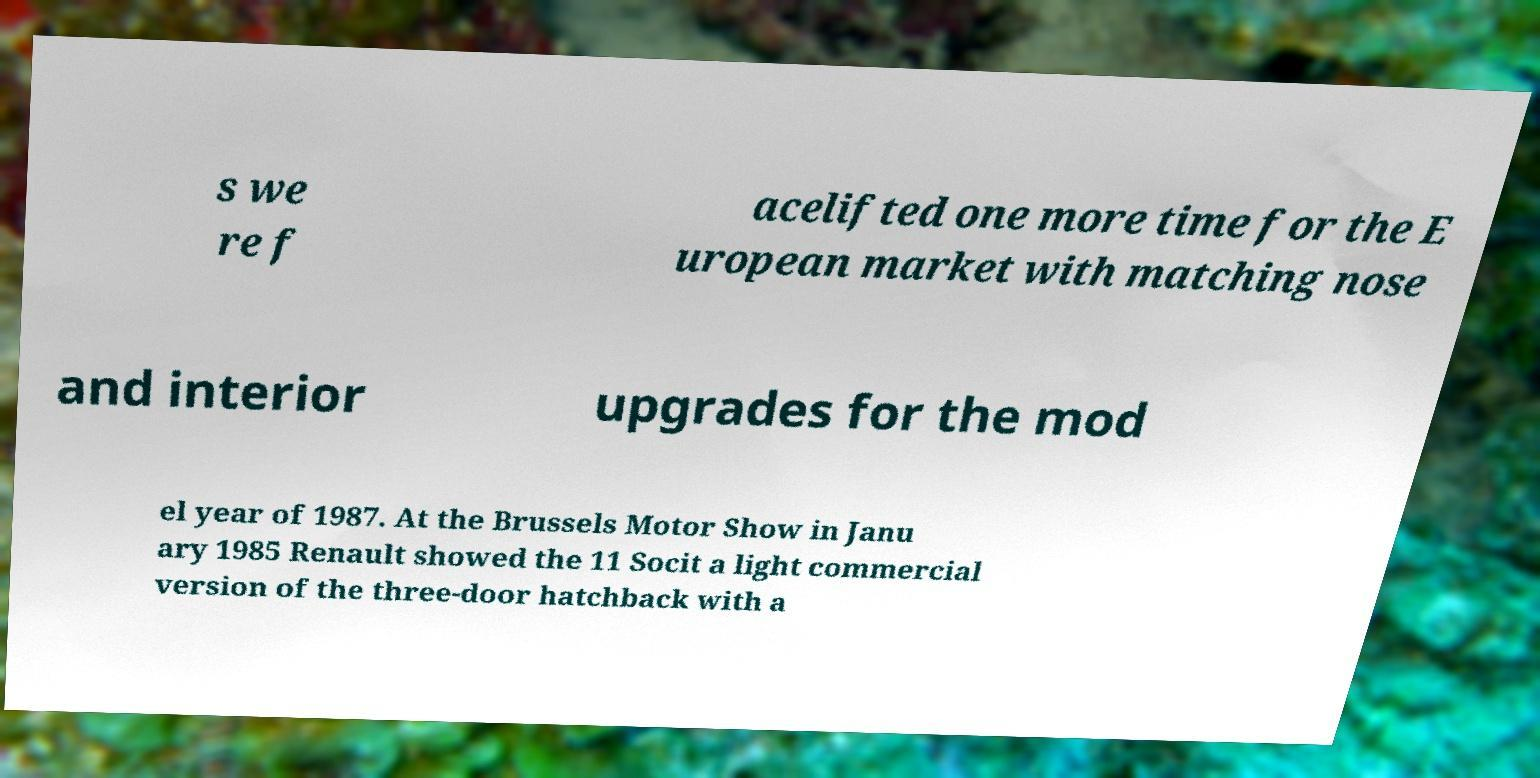Please identify and transcribe the text found in this image. s we re f acelifted one more time for the E uropean market with matching nose and interior upgrades for the mod el year of 1987. At the Brussels Motor Show in Janu ary 1985 Renault showed the 11 Socit a light commercial version of the three-door hatchback with a 